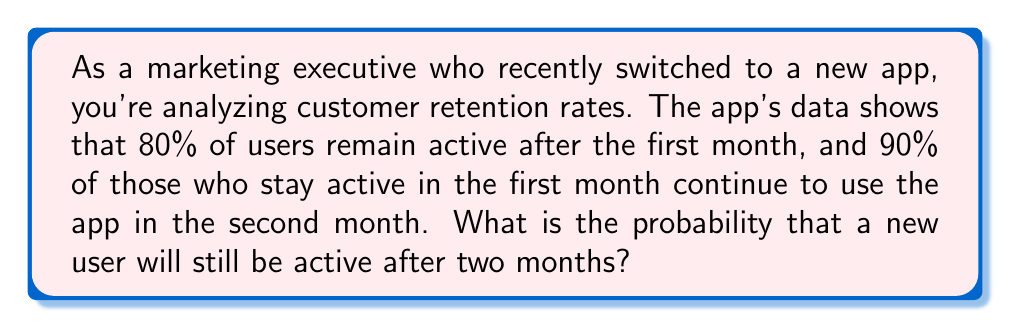Teach me how to tackle this problem. To solve this problem, we need to use the concept of conditional probability.

Let's define our events:
A = User remains active after the first month
B = User remains active after the second month, given they were active after the first month

We're given:
P(A) = 0.80 (80% of users remain active after the first month)
P(B|A) = 0.90 (90% of users who stay active in the first month continue to use the app in the second month)

We want to find P(A and B), which is the probability that a user remains active after both the first and second months.

Using the multiplication rule of probability:

$$ P(A \text{ and } B) = P(A) \cdot P(B|A) $$

Substituting our known values:

$$ P(A \text{ and } B) = 0.80 \cdot 0.90 $$

$$ P(A \text{ and } B) = 0.72 $$

Therefore, the probability that a new user will still be active after two months is 0.72 or 72%.
Answer: 0.72 or 72% 